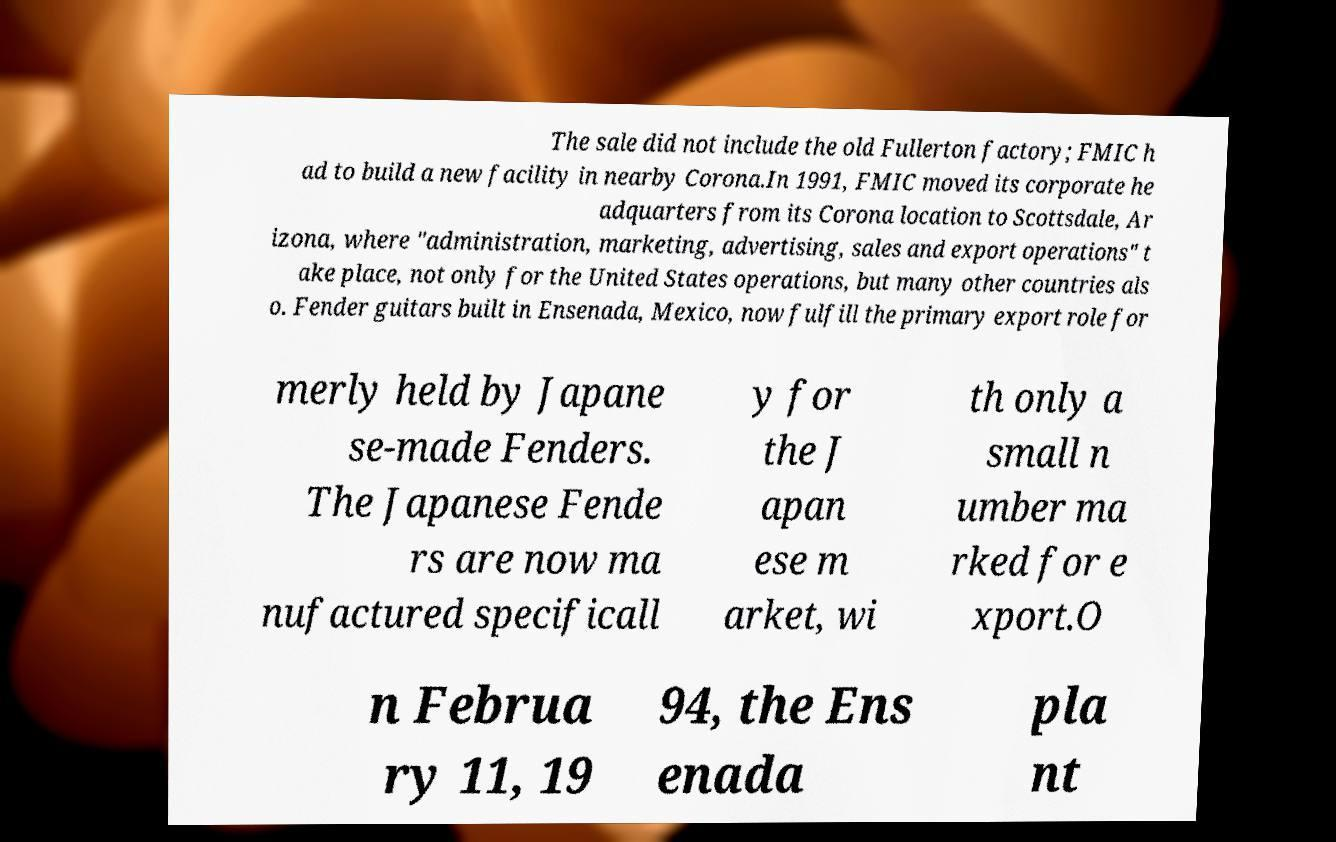Can you accurately transcribe the text from the provided image for me? The sale did not include the old Fullerton factory; FMIC h ad to build a new facility in nearby Corona.In 1991, FMIC moved its corporate he adquarters from its Corona location to Scottsdale, Ar izona, where "administration, marketing, advertising, sales and export operations" t ake place, not only for the United States operations, but many other countries als o. Fender guitars built in Ensenada, Mexico, now fulfill the primary export role for merly held by Japane se-made Fenders. The Japanese Fende rs are now ma nufactured specificall y for the J apan ese m arket, wi th only a small n umber ma rked for e xport.O n Februa ry 11, 19 94, the Ens enada pla nt 